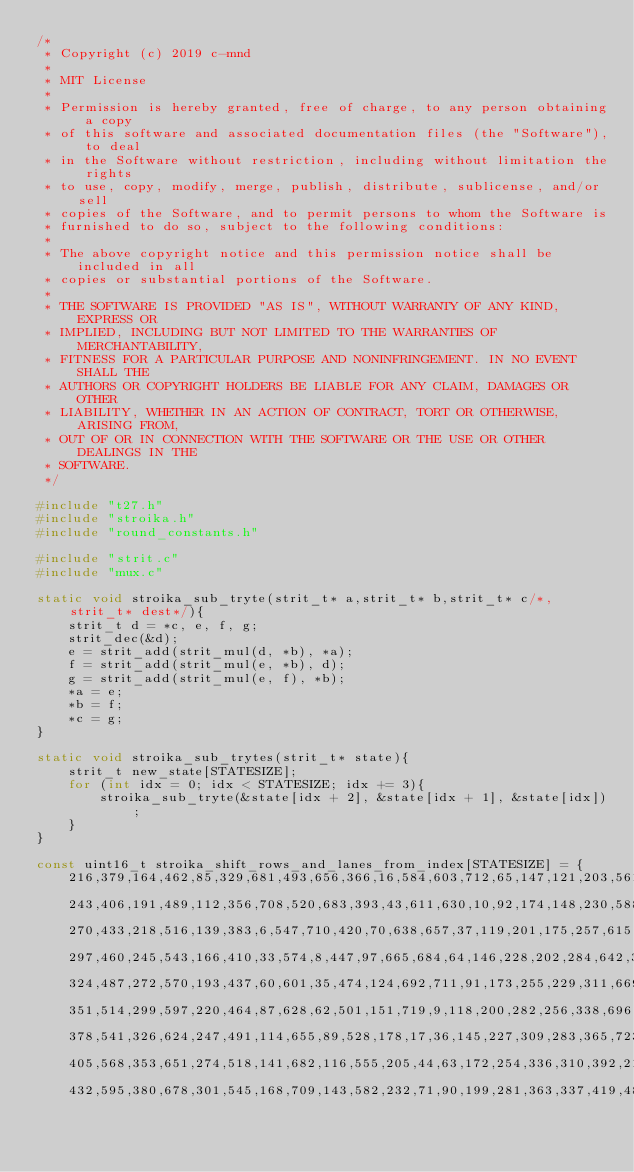<code> <loc_0><loc_0><loc_500><loc_500><_C_>/*
 * Copyright (c) 2019 c-mnd
 *
 * MIT License
 *
 * Permission is hereby granted, free of charge, to any person obtaining a copy
 * of this software and associated documentation files (the "Software"), to deal
 * in the Software without restriction, including without limitation the rights
 * to use, copy, modify, merge, publish, distribute, sublicense, and/or sell
 * copies of the Software, and to permit persons to whom the Software is
 * furnished to do so, subject to the following conditions:
 *
 * The above copyright notice and this permission notice shall be included in all
 * copies or substantial portions of the Software.
 *
 * THE SOFTWARE IS PROVIDED "AS IS", WITHOUT WARRANTY OF ANY KIND, EXPRESS OR
 * IMPLIED, INCLUDING BUT NOT LIMITED TO THE WARRANTIES OF MERCHANTABILITY,
 * FITNESS FOR A PARTICULAR PURPOSE AND NONINFRINGEMENT. IN NO EVENT SHALL THE
 * AUTHORS OR COPYRIGHT HOLDERS BE LIABLE FOR ANY CLAIM, DAMAGES OR OTHER
 * LIABILITY, WHETHER IN AN ACTION OF CONTRACT, TORT OR OTHERWISE, ARISING FROM,
 * OUT OF OR IN CONNECTION WITH THE SOFTWARE OR THE USE OR OTHER DEALINGS IN THE
 * SOFTWARE.
 */

#include "t27.h"
#include "stroika.h"
#include "round_constants.h"

#include "strit.c"
#include "mux.c"

static void stroika_sub_tryte(strit_t* a,strit_t* b,strit_t* c/*, strit_t* dest*/){
    strit_t d = *c, e, f, g;
    strit_dec(&d);
    e = strit_add(strit_mul(d, *b), *a);
    f = strit_add(strit_mul(e, *b), d);
    g = strit_add(strit_mul(e, f), *b);
    *a = e;
    *b = f;
    *c = g;
}

static void stroika_sub_trytes(strit_t* state){
    strit_t new_state[STATESIZE];
    for (int idx = 0; idx < STATESIZE; idx += 3){
        stroika_sub_tryte(&state[idx + 2], &state[idx + 1], &state[idx]);
    }
}

const uint16_t stroika_shift_rows_and_lanes_from_index[STATESIZE] = {
    216,379,164,462,85,329,681,493,656,366,16,584,603,712,65,147,121,203,561,292,50,429,538,269,315,451,641,
    243,406,191,489,112,356,708,520,683,393,43,611,630,10,92,174,148,230,588,319,77,456,565,296,342,478,668,
    270,433,218,516,139,383,6,547,710,420,70,638,657,37,119,201,175,257,615,346,104,483,592,323,369,505,695,
    297,460,245,543,166,410,33,574,8,447,97,665,684,64,146,228,202,284,642,373,131,510,619,350,396,532,722,
    324,487,272,570,193,437,60,601,35,474,124,692,711,91,173,255,229,311,669,400,158,537,646,377,423,559,20,
    351,514,299,597,220,464,87,628,62,501,151,719,9,118,200,282,256,338,696,427,185,564,673,404,450,586,47,
    378,541,326,624,247,491,114,655,89,528,178,17,36,145,227,309,283,365,723,454,212,591,700,431,477,613,74,
    405,568,353,651,274,518,141,682,116,555,205,44,63,172,254,336,310,392,21,481,239,618,727,458,504,640,101,
    432,595,380,678,301,545,168,709,143,582,232,71,90,199,281,363,337,419,48,508,266,645,25,485,531,667,128,</code> 